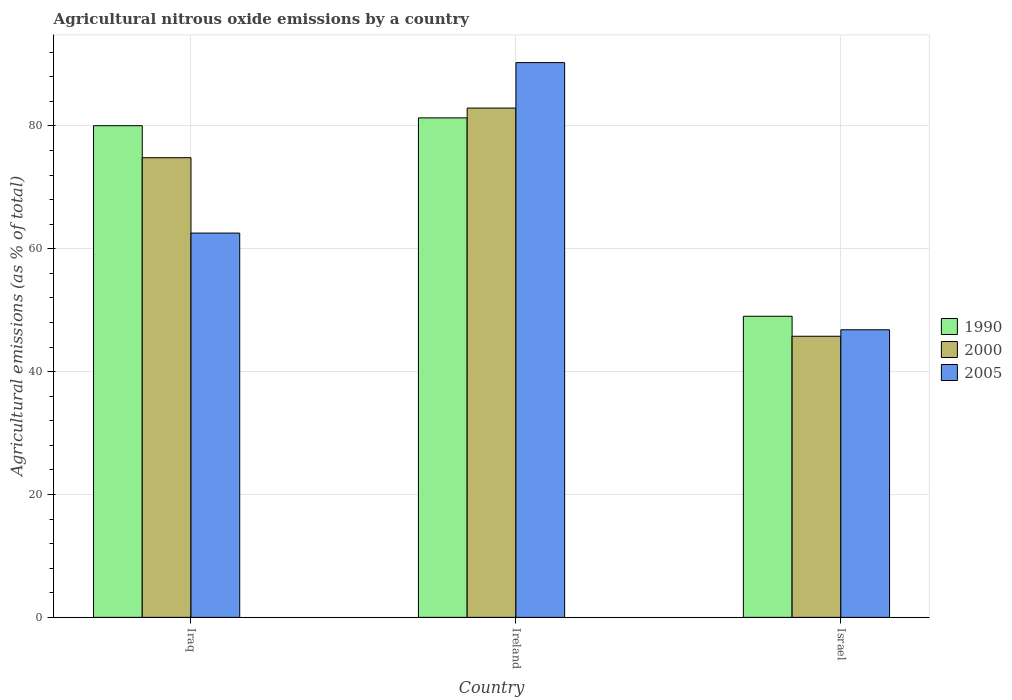Are the number of bars per tick equal to the number of legend labels?
Your answer should be very brief. Yes. Are the number of bars on each tick of the X-axis equal?
Offer a very short reply. Yes. What is the label of the 1st group of bars from the left?
Offer a terse response. Iraq. In how many cases, is the number of bars for a given country not equal to the number of legend labels?
Provide a succinct answer. 0. What is the amount of agricultural nitrous oxide emitted in 1990 in Ireland?
Make the answer very short. 81.31. Across all countries, what is the maximum amount of agricultural nitrous oxide emitted in 2000?
Ensure brevity in your answer.  82.91. Across all countries, what is the minimum amount of agricultural nitrous oxide emitted in 1990?
Offer a terse response. 49.02. In which country was the amount of agricultural nitrous oxide emitted in 2005 maximum?
Keep it short and to the point. Ireland. What is the total amount of agricultural nitrous oxide emitted in 2005 in the graph?
Your answer should be compact. 199.68. What is the difference between the amount of agricultural nitrous oxide emitted in 1990 in Ireland and that in Israel?
Ensure brevity in your answer.  32.29. What is the difference between the amount of agricultural nitrous oxide emitted in 2000 in Ireland and the amount of agricultural nitrous oxide emitted in 2005 in Iraq?
Offer a very short reply. 20.35. What is the average amount of agricultural nitrous oxide emitted in 2005 per country?
Your response must be concise. 66.56. What is the difference between the amount of agricultural nitrous oxide emitted of/in 2005 and amount of agricultural nitrous oxide emitted of/in 2000 in Iraq?
Provide a short and direct response. -12.27. In how many countries, is the amount of agricultural nitrous oxide emitted in 2000 greater than 84 %?
Make the answer very short. 0. What is the ratio of the amount of agricultural nitrous oxide emitted in 2005 in Iraq to that in Israel?
Keep it short and to the point. 1.34. Is the amount of agricultural nitrous oxide emitted in 2000 in Ireland less than that in Israel?
Offer a very short reply. No. Is the difference between the amount of agricultural nitrous oxide emitted in 2005 in Iraq and Israel greater than the difference between the amount of agricultural nitrous oxide emitted in 2000 in Iraq and Israel?
Ensure brevity in your answer.  No. What is the difference between the highest and the second highest amount of agricultural nitrous oxide emitted in 2005?
Provide a short and direct response. -43.49. What is the difference between the highest and the lowest amount of agricultural nitrous oxide emitted in 2005?
Provide a short and direct response. 43.49. In how many countries, is the amount of agricultural nitrous oxide emitted in 1990 greater than the average amount of agricultural nitrous oxide emitted in 1990 taken over all countries?
Provide a short and direct response. 2. What does the 3rd bar from the right in Iraq represents?
Provide a succinct answer. 1990. Is it the case that in every country, the sum of the amount of agricultural nitrous oxide emitted in 1990 and amount of agricultural nitrous oxide emitted in 2005 is greater than the amount of agricultural nitrous oxide emitted in 2000?
Provide a succinct answer. Yes. Are all the bars in the graph horizontal?
Offer a very short reply. No. What is the difference between two consecutive major ticks on the Y-axis?
Make the answer very short. 20. Does the graph contain grids?
Provide a succinct answer. Yes. What is the title of the graph?
Your response must be concise. Agricultural nitrous oxide emissions by a country. What is the label or title of the Y-axis?
Keep it short and to the point. Agricultural emissions (as % of total). What is the Agricultural emissions (as % of total) of 1990 in Iraq?
Your answer should be very brief. 80.04. What is the Agricultural emissions (as % of total) in 2000 in Iraq?
Your answer should be compact. 74.83. What is the Agricultural emissions (as % of total) in 2005 in Iraq?
Your response must be concise. 62.56. What is the Agricultural emissions (as % of total) in 1990 in Ireland?
Provide a short and direct response. 81.31. What is the Agricultural emissions (as % of total) in 2000 in Ireland?
Your answer should be compact. 82.91. What is the Agricultural emissions (as % of total) of 2005 in Ireland?
Ensure brevity in your answer.  90.31. What is the Agricultural emissions (as % of total) in 1990 in Israel?
Offer a very short reply. 49.02. What is the Agricultural emissions (as % of total) in 2000 in Israel?
Your response must be concise. 45.76. What is the Agricultural emissions (as % of total) of 2005 in Israel?
Your answer should be compact. 46.82. Across all countries, what is the maximum Agricultural emissions (as % of total) of 1990?
Keep it short and to the point. 81.31. Across all countries, what is the maximum Agricultural emissions (as % of total) of 2000?
Your answer should be very brief. 82.91. Across all countries, what is the maximum Agricultural emissions (as % of total) in 2005?
Your answer should be compact. 90.31. Across all countries, what is the minimum Agricultural emissions (as % of total) in 1990?
Your response must be concise. 49.02. Across all countries, what is the minimum Agricultural emissions (as % of total) in 2000?
Provide a succinct answer. 45.76. Across all countries, what is the minimum Agricultural emissions (as % of total) of 2005?
Offer a very short reply. 46.82. What is the total Agricultural emissions (as % of total) of 1990 in the graph?
Make the answer very short. 210.37. What is the total Agricultural emissions (as % of total) in 2000 in the graph?
Offer a terse response. 203.5. What is the total Agricultural emissions (as % of total) in 2005 in the graph?
Keep it short and to the point. 199.68. What is the difference between the Agricultural emissions (as % of total) of 1990 in Iraq and that in Ireland?
Make the answer very short. -1.27. What is the difference between the Agricultural emissions (as % of total) in 2000 in Iraq and that in Ireland?
Provide a succinct answer. -8.08. What is the difference between the Agricultural emissions (as % of total) of 2005 in Iraq and that in Ireland?
Provide a short and direct response. -27.75. What is the difference between the Agricultural emissions (as % of total) in 1990 in Iraq and that in Israel?
Make the answer very short. 31.02. What is the difference between the Agricultural emissions (as % of total) in 2000 in Iraq and that in Israel?
Provide a succinct answer. 29.07. What is the difference between the Agricultural emissions (as % of total) of 2005 in Iraq and that in Israel?
Your response must be concise. 15.74. What is the difference between the Agricultural emissions (as % of total) in 1990 in Ireland and that in Israel?
Your answer should be compact. 32.29. What is the difference between the Agricultural emissions (as % of total) in 2000 in Ireland and that in Israel?
Make the answer very short. 37.15. What is the difference between the Agricultural emissions (as % of total) of 2005 in Ireland and that in Israel?
Make the answer very short. 43.49. What is the difference between the Agricultural emissions (as % of total) of 1990 in Iraq and the Agricultural emissions (as % of total) of 2000 in Ireland?
Your answer should be very brief. -2.87. What is the difference between the Agricultural emissions (as % of total) of 1990 in Iraq and the Agricultural emissions (as % of total) of 2005 in Ireland?
Ensure brevity in your answer.  -10.27. What is the difference between the Agricultural emissions (as % of total) in 2000 in Iraq and the Agricultural emissions (as % of total) in 2005 in Ireland?
Your answer should be compact. -15.48. What is the difference between the Agricultural emissions (as % of total) in 1990 in Iraq and the Agricultural emissions (as % of total) in 2000 in Israel?
Give a very brief answer. 34.28. What is the difference between the Agricultural emissions (as % of total) of 1990 in Iraq and the Agricultural emissions (as % of total) of 2005 in Israel?
Provide a short and direct response. 33.22. What is the difference between the Agricultural emissions (as % of total) of 2000 in Iraq and the Agricultural emissions (as % of total) of 2005 in Israel?
Your response must be concise. 28.01. What is the difference between the Agricultural emissions (as % of total) of 1990 in Ireland and the Agricultural emissions (as % of total) of 2000 in Israel?
Give a very brief answer. 35.55. What is the difference between the Agricultural emissions (as % of total) in 1990 in Ireland and the Agricultural emissions (as % of total) in 2005 in Israel?
Offer a terse response. 34.49. What is the difference between the Agricultural emissions (as % of total) of 2000 in Ireland and the Agricultural emissions (as % of total) of 2005 in Israel?
Your answer should be compact. 36.09. What is the average Agricultural emissions (as % of total) in 1990 per country?
Give a very brief answer. 70.12. What is the average Agricultural emissions (as % of total) in 2000 per country?
Your answer should be compact. 67.83. What is the average Agricultural emissions (as % of total) of 2005 per country?
Make the answer very short. 66.56. What is the difference between the Agricultural emissions (as % of total) in 1990 and Agricultural emissions (as % of total) in 2000 in Iraq?
Offer a very short reply. 5.21. What is the difference between the Agricultural emissions (as % of total) in 1990 and Agricultural emissions (as % of total) in 2005 in Iraq?
Ensure brevity in your answer.  17.48. What is the difference between the Agricultural emissions (as % of total) of 2000 and Agricultural emissions (as % of total) of 2005 in Iraq?
Your answer should be compact. 12.27. What is the difference between the Agricultural emissions (as % of total) of 1990 and Agricultural emissions (as % of total) of 2000 in Ireland?
Make the answer very short. -1.6. What is the difference between the Agricultural emissions (as % of total) in 1990 and Agricultural emissions (as % of total) in 2005 in Ireland?
Your answer should be very brief. -9. What is the difference between the Agricultural emissions (as % of total) of 2000 and Agricultural emissions (as % of total) of 2005 in Ireland?
Give a very brief answer. -7.4. What is the difference between the Agricultural emissions (as % of total) of 1990 and Agricultural emissions (as % of total) of 2000 in Israel?
Your answer should be compact. 3.26. What is the difference between the Agricultural emissions (as % of total) of 1990 and Agricultural emissions (as % of total) of 2005 in Israel?
Keep it short and to the point. 2.2. What is the difference between the Agricultural emissions (as % of total) of 2000 and Agricultural emissions (as % of total) of 2005 in Israel?
Keep it short and to the point. -1.06. What is the ratio of the Agricultural emissions (as % of total) of 1990 in Iraq to that in Ireland?
Ensure brevity in your answer.  0.98. What is the ratio of the Agricultural emissions (as % of total) of 2000 in Iraq to that in Ireland?
Offer a very short reply. 0.9. What is the ratio of the Agricultural emissions (as % of total) in 2005 in Iraq to that in Ireland?
Make the answer very short. 0.69. What is the ratio of the Agricultural emissions (as % of total) of 1990 in Iraq to that in Israel?
Provide a succinct answer. 1.63. What is the ratio of the Agricultural emissions (as % of total) in 2000 in Iraq to that in Israel?
Give a very brief answer. 1.64. What is the ratio of the Agricultural emissions (as % of total) in 2005 in Iraq to that in Israel?
Keep it short and to the point. 1.34. What is the ratio of the Agricultural emissions (as % of total) in 1990 in Ireland to that in Israel?
Keep it short and to the point. 1.66. What is the ratio of the Agricultural emissions (as % of total) in 2000 in Ireland to that in Israel?
Your response must be concise. 1.81. What is the ratio of the Agricultural emissions (as % of total) in 2005 in Ireland to that in Israel?
Provide a short and direct response. 1.93. What is the difference between the highest and the second highest Agricultural emissions (as % of total) of 1990?
Ensure brevity in your answer.  1.27. What is the difference between the highest and the second highest Agricultural emissions (as % of total) of 2000?
Your answer should be very brief. 8.08. What is the difference between the highest and the second highest Agricultural emissions (as % of total) in 2005?
Keep it short and to the point. 27.75. What is the difference between the highest and the lowest Agricultural emissions (as % of total) of 1990?
Make the answer very short. 32.29. What is the difference between the highest and the lowest Agricultural emissions (as % of total) of 2000?
Your answer should be very brief. 37.15. What is the difference between the highest and the lowest Agricultural emissions (as % of total) of 2005?
Offer a very short reply. 43.49. 